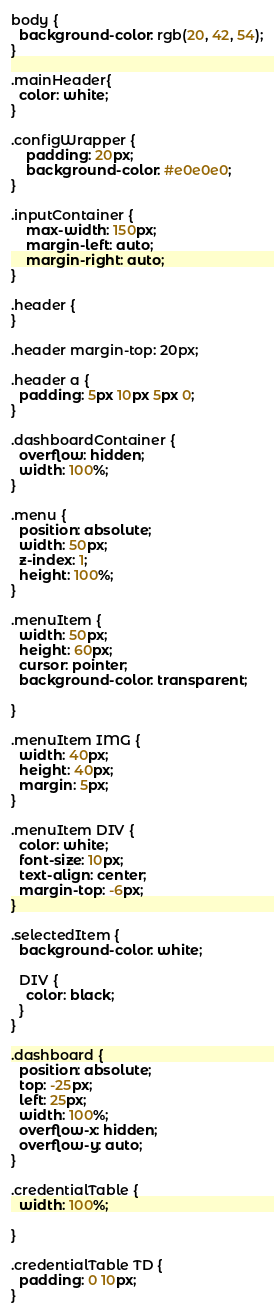Convert code to text. <code><loc_0><loc_0><loc_500><loc_500><_CSS_>body {
  background-color: rgb(20, 42, 54);
}

.mainHeader{
  color: white;
}

.configWrapper {
	padding: 20px;
	background-color: #e0e0e0;
}

.inputContainer {
    max-width: 150px;
    margin-left: auto;
    margin-right: auto;
}

.header {
}

.header margin-top: 20px;

.header a {
  padding: 5px 10px 5px 0;
}

.dashboardContainer {
  overflow: hidden;
  width: 100%;
}

.menu {
  position: absolute;
  width: 50px;
  z-index: 1;
  height: 100%;
}

.menuItem {
  width: 50px;
  height: 60px;
  cursor: pointer;
  background-color: transparent;

}

.menuItem IMG {
  width: 40px;
  height: 40px;
  margin: 5px;
}

.menuItem DIV {
  color: white;
  font-size: 10px;
  text-align: center;
  margin-top: -6px;
}

.selectedItem {
  background-color: white;

  DIV {
    color: black;
  }
}

.dashboard {
  position: absolute;
  top: -25px;
  left: 25px;
  width: 100%;
  overflow-x: hidden;
  overflow-y: auto;
}

.credentialTable {
  width: 100%;

}

.credentialTable TD {
  padding: 0 10px;
}
</code> 